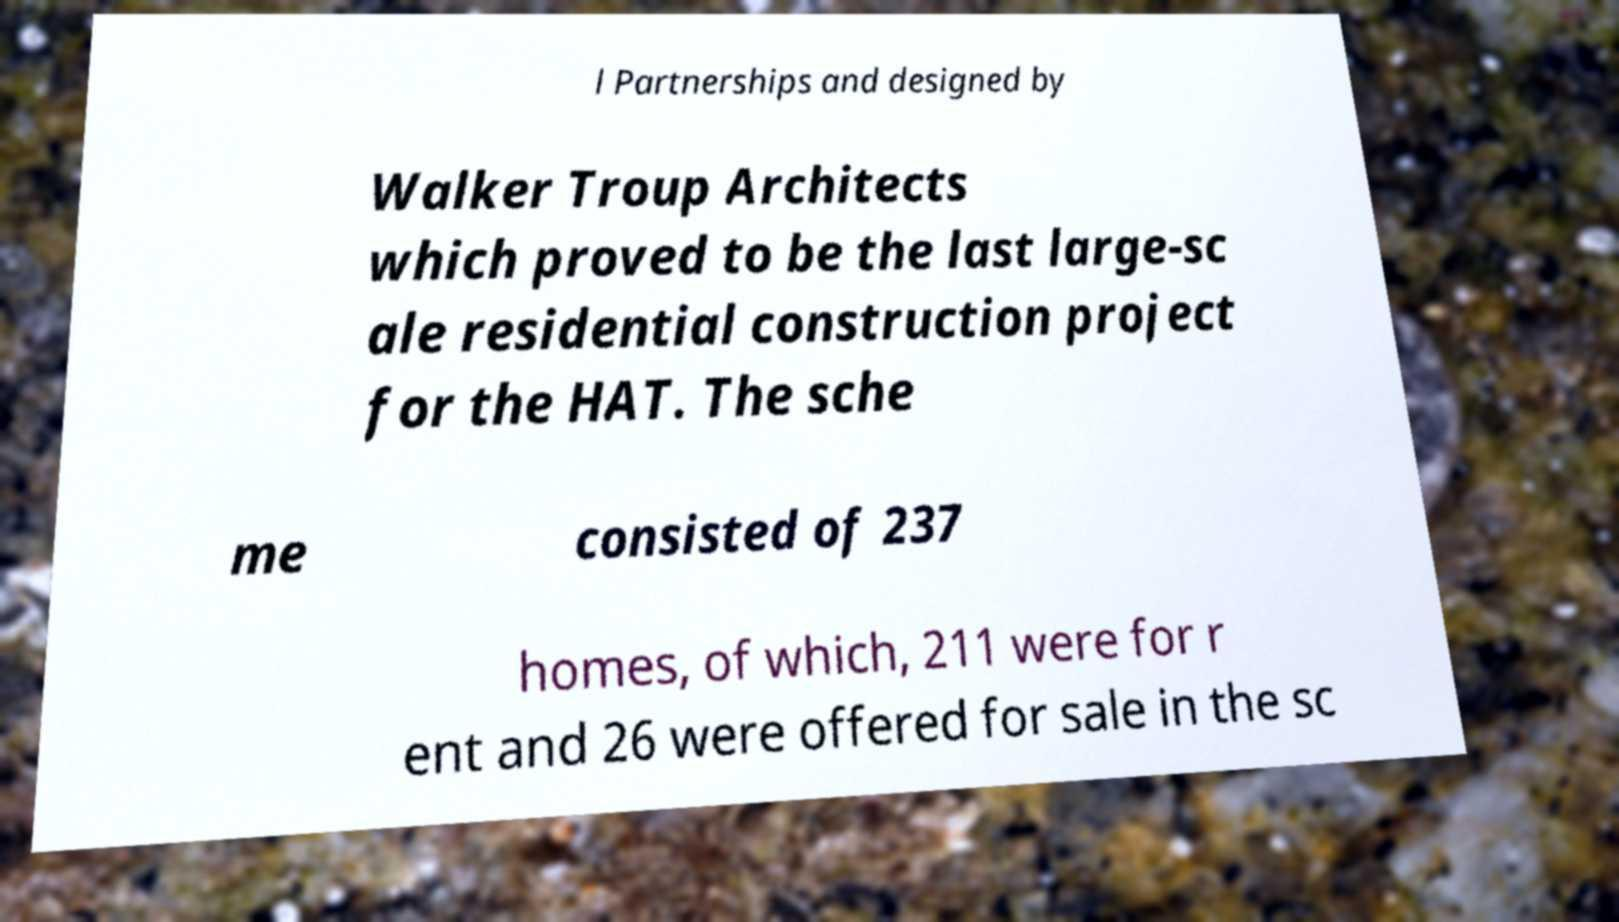Can you read and provide the text displayed in the image?This photo seems to have some interesting text. Can you extract and type it out for me? l Partnerships and designed by Walker Troup Architects which proved to be the last large-sc ale residential construction project for the HAT. The sche me consisted of 237 homes, of which, 211 were for r ent and 26 were offered for sale in the sc 